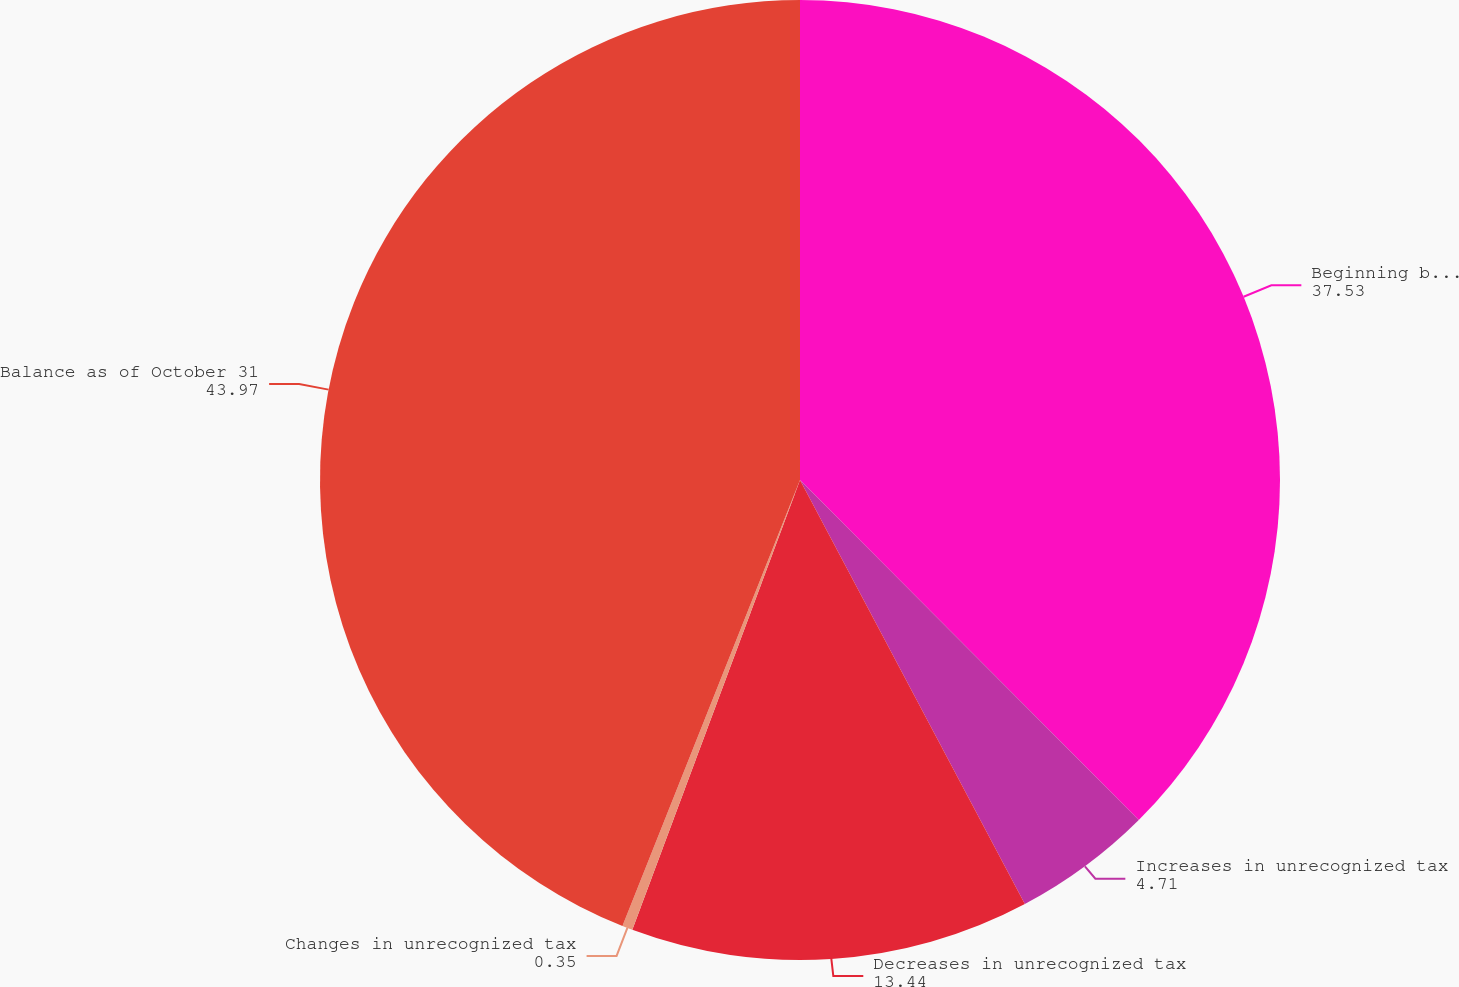Convert chart to OTSL. <chart><loc_0><loc_0><loc_500><loc_500><pie_chart><fcel>Beginning balance<fcel>Increases in unrecognized tax<fcel>Decreases in unrecognized tax<fcel>Changes in unrecognized tax<fcel>Balance as of October 31<nl><fcel>37.53%<fcel>4.71%<fcel>13.44%<fcel>0.35%<fcel>43.97%<nl></chart> 